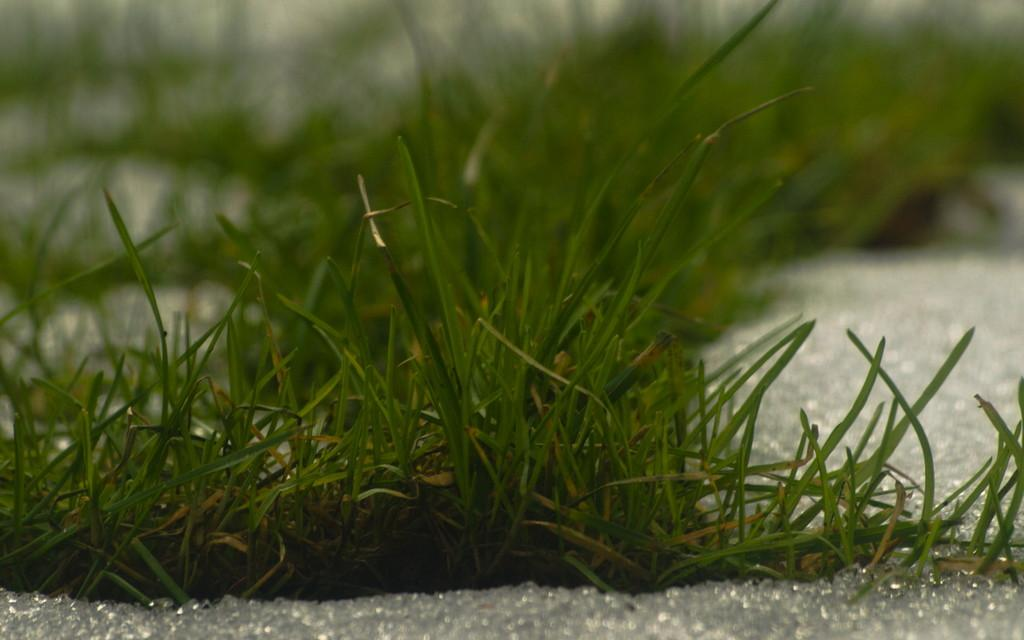What type of vegetation is present on the ground in the image? There is green color grass on the ground in the image. Can you describe the background of the image? The background of the image is blurred. What type of lock can be seen securing the ice on the swing in the image? There is no lock, ice, or swing present in the image. 